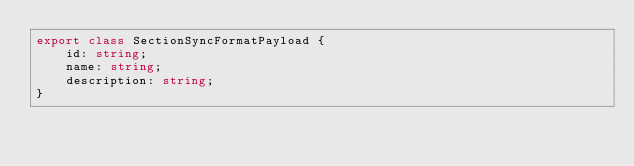<code> <loc_0><loc_0><loc_500><loc_500><_TypeScript_>export class SectionSyncFormatPayload {
    id: string;
    name: string;
    description: string;
}
</code> 